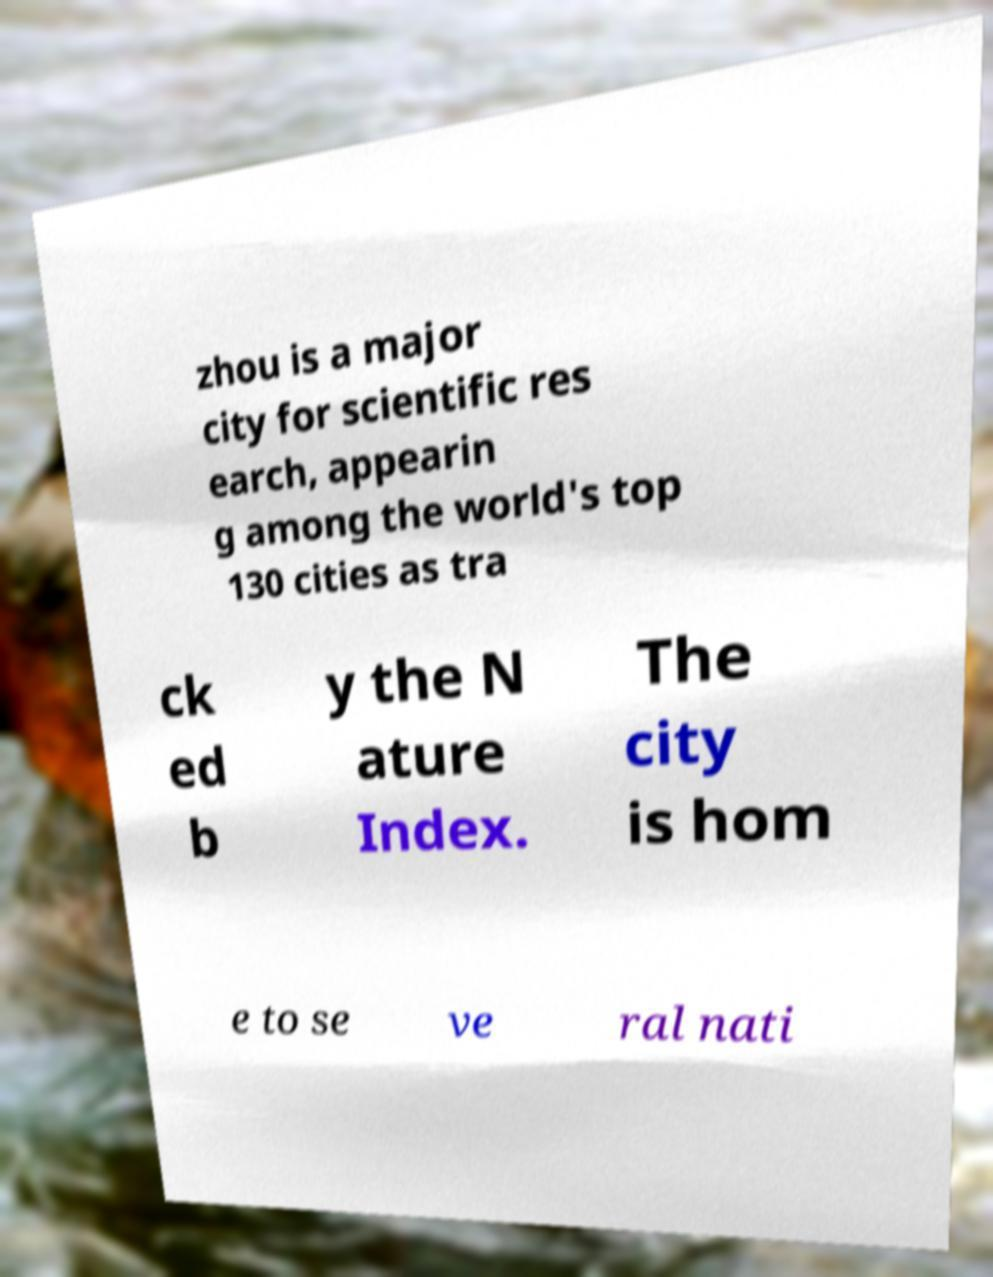I need the written content from this picture converted into text. Can you do that? zhou is a major city for scientific res earch, appearin g among the world's top 130 cities as tra ck ed b y the N ature Index. The city is hom e to se ve ral nati 